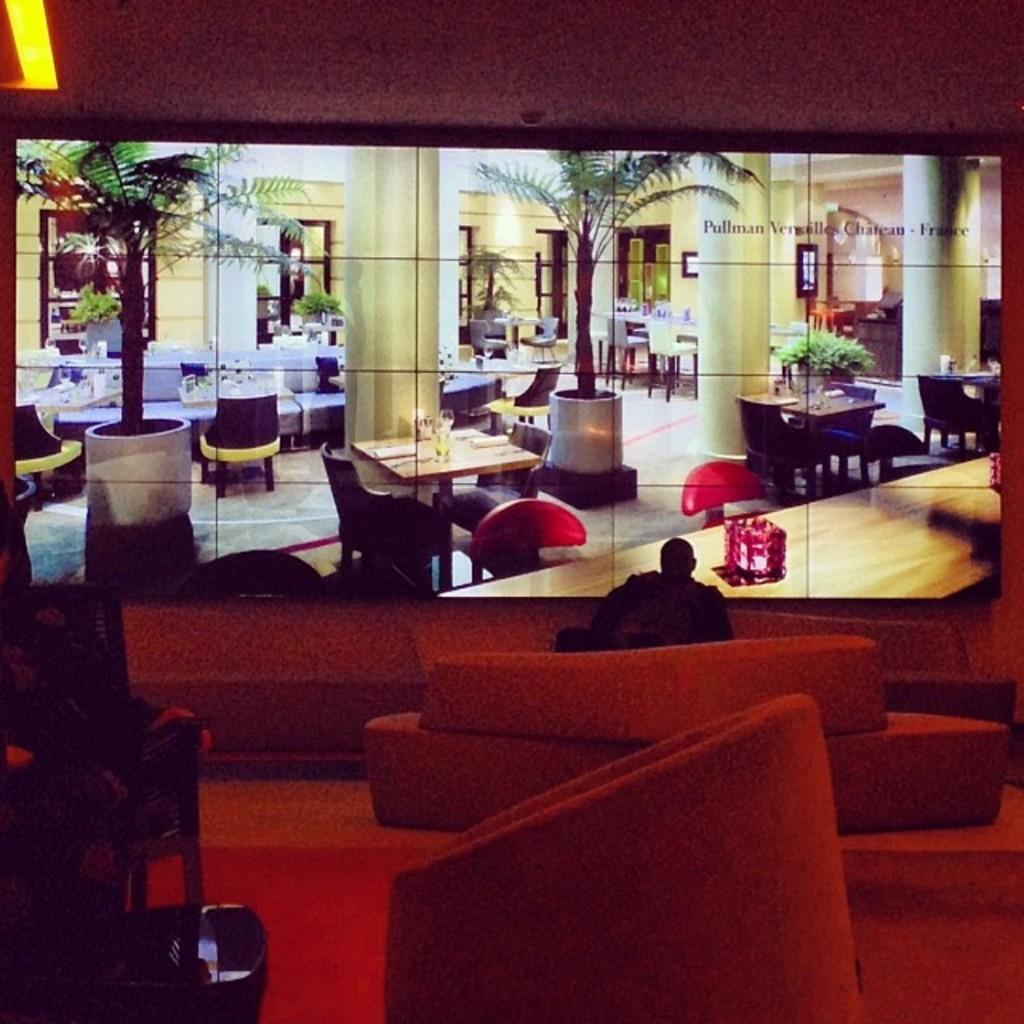What is the main subject of the image? There is a person in the image. What is the person doing in the image? The person is sitting. What else can be seen in the image besides the person? There is a picture in the image. What type of sweater is the person wearing in the image? There is no information about the person's clothing in the image, so we cannot determine if they are wearing a sweater or any other type of clothing. 